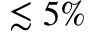Convert formula to latex. <formula><loc_0><loc_0><loc_500><loc_500>\lesssim 5 \%</formula> 